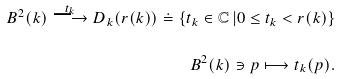<formula> <loc_0><loc_0><loc_500><loc_500>B ^ { 2 } ( k ) \overset { t _ { k } } { \longrightarrow } D _ { k } ( r ( k ) ) \doteq \left \{ t _ { k } \in \mathbb { C } \, | 0 \leq t _ { k } < r ( k ) \right \} \\ B ^ { 2 } ( k ) \ni p \longmapsto t _ { k } ( p ) .</formula> 